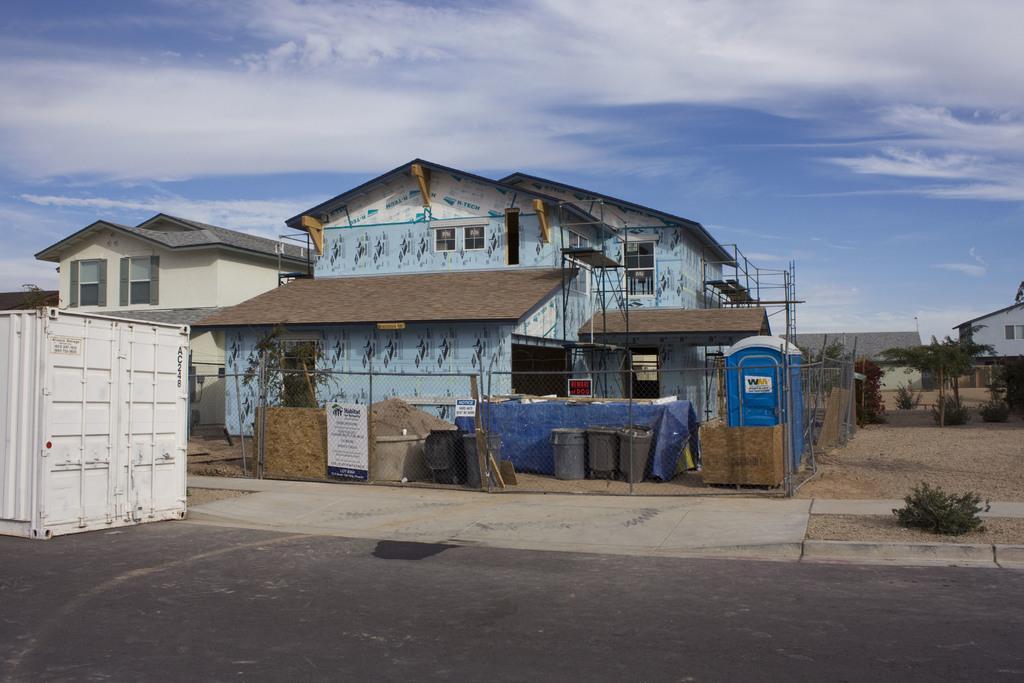Can you describe this image briefly? In this image we can see few houses and buildings. We can see the sky and clouds in the image. There is a fence in the image. There a board on the fence. There are many plants in the image. There is a container at the left side of the image. There is a road in the image. There are many objects on the ground in the image. 